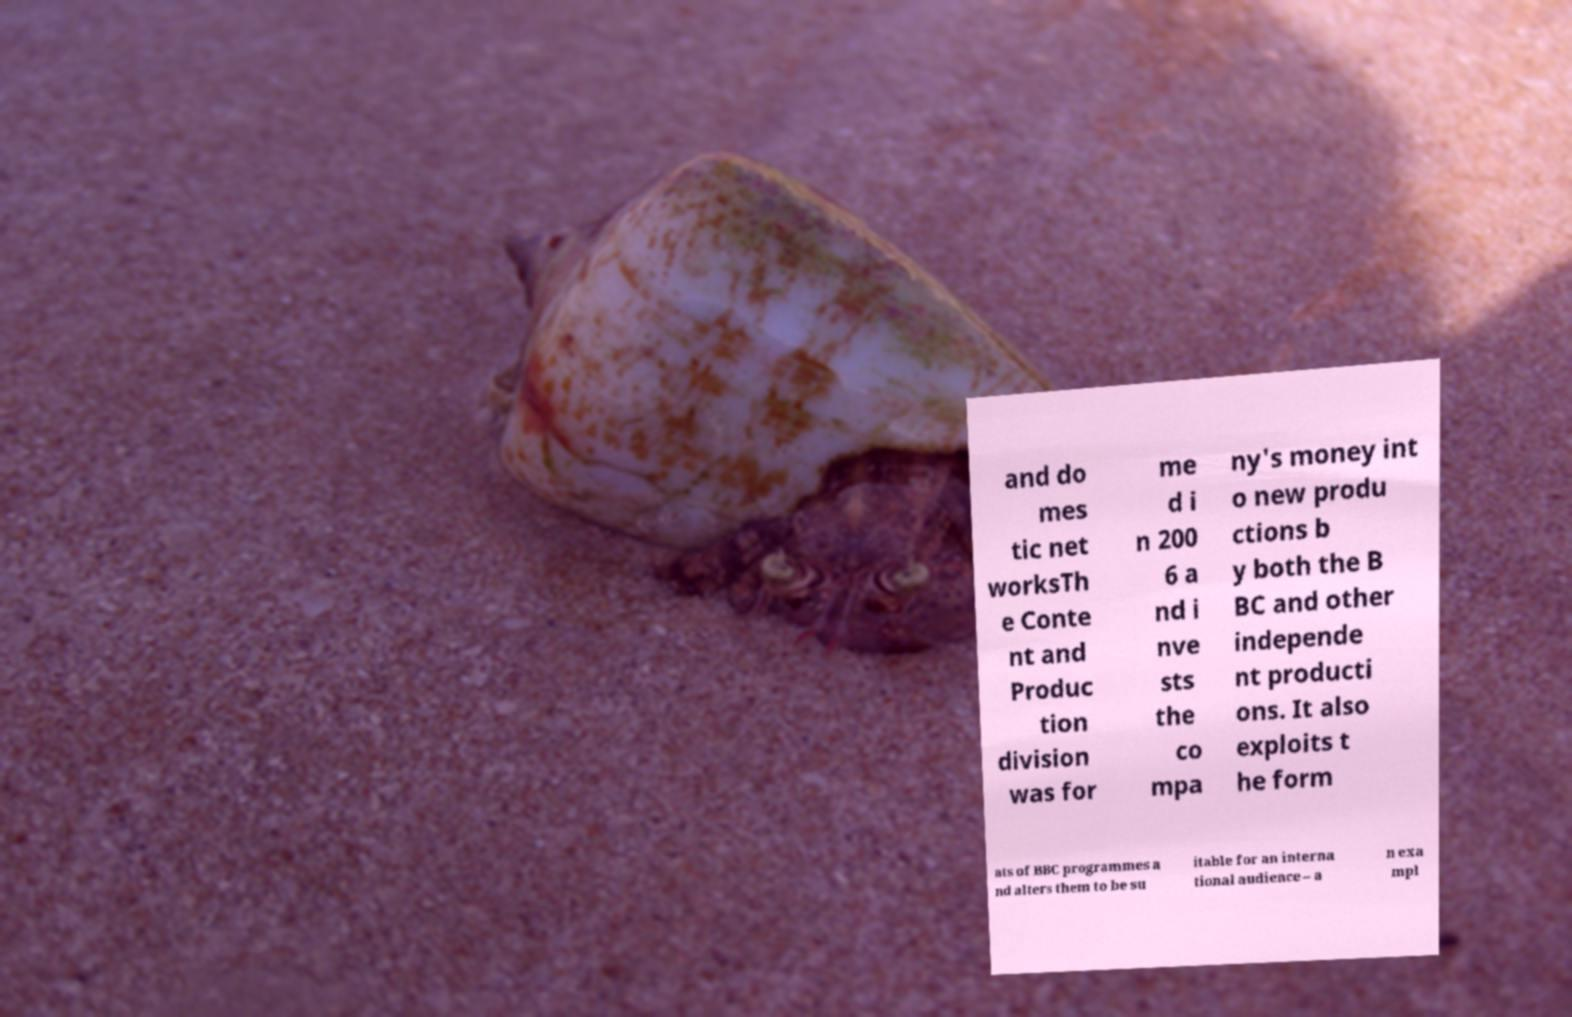What messages or text are displayed in this image? I need them in a readable, typed format. and do mes tic net worksTh e Conte nt and Produc tion division was for me d i n 200 6 a nd i nve sts the co mpa ny's money int o new produ ctions b y both the B BC and other independe nt producti ons. It also exploits t he form ats of BBC programmes a nd alters them to be su itable for an interna tional audience – a n exa mpl 